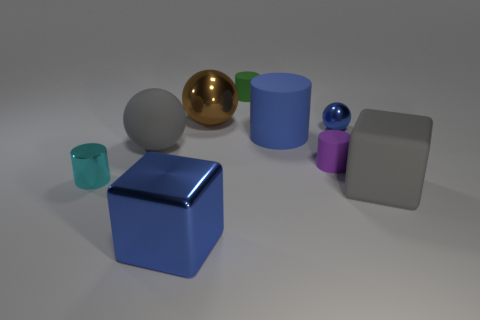Are there any big cylinders of the same color as the shiny block?
Your answer should be very brief. Yes. There is a big metal object that is the same color as the large cylinder; what is its shape?
Give a very brief answer. Cube. What color is the large object that is the same shape as the tiny cyan shiny thing?
Provide a short and direct response. Blue. Do the sphere that is in front of the small metal ball and the small green thing have the same material?
Your answer should be compact. Yes. What number of tiny objects are objects or purple things?
Your answer should be very brief. 4. How big is the metallic block?
Your answer should be very brief. Large. Do the gray rubber block and the blue metallic object in front of the tiny cyan cylinder have the same size?
Your answer should be compact. Yes. What number of gray objects are big things or large metal spheres?
Your answer should be very brief. 2. What number of green rubber objects are there?
Make the answer very short. 1. What size is the cylinder that is behind the tiny sphere?
Keep it short and to the point. Small. 